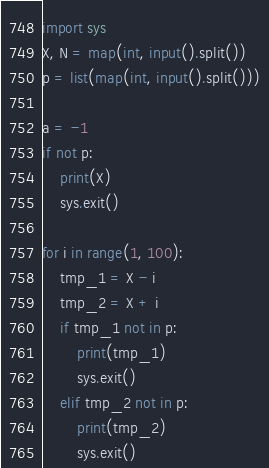Convert code to text. <code><loc_0><loc_0><loc_500><loc_500><_Python_>import sys
X, N = map(int, input().split())
p = list(map(int, input().split()))

a = -1
if not p:
    print(X)
    sys.exit()

for i in range(1, 100):
    tmp_1 = X - i
    tmp_2 = X + i
    if tmp_1 not in p:
        print(tmp_1)
        sys.exit()
    elif tmp_2 not in p:
        print(tmp_2)
        sys.exit()</code> 